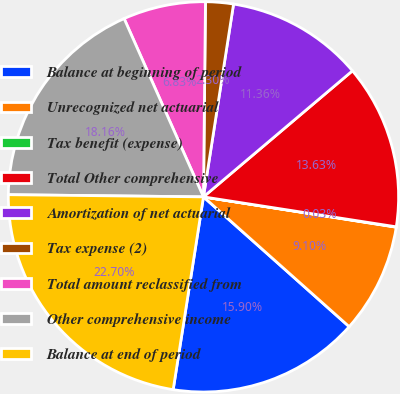Convert chart to OTSL. <chart><loc_0><loc_0><loc_500><loc_500><pie_chart><fcel>Balance at beginning of period<fcel>Unrecognized net actuarial<fcel>Tax benefit (expense)<fcel>Total Other comprehensive<fcel>Amortization of net actuarial<fcel>Tax expense (2)<fcel>Total amount reclassified from<fcel>Other comprehensive income<fcel>Balance at end of period<nl><fcel>15.9%<fcel>9.1%<fcel>0.03%<fcel>13.63%<fcel>11.36%<fcel>2.3%<fcel>6.83%<fcel>18.16%<fcel>22.7%<nl></chart> 